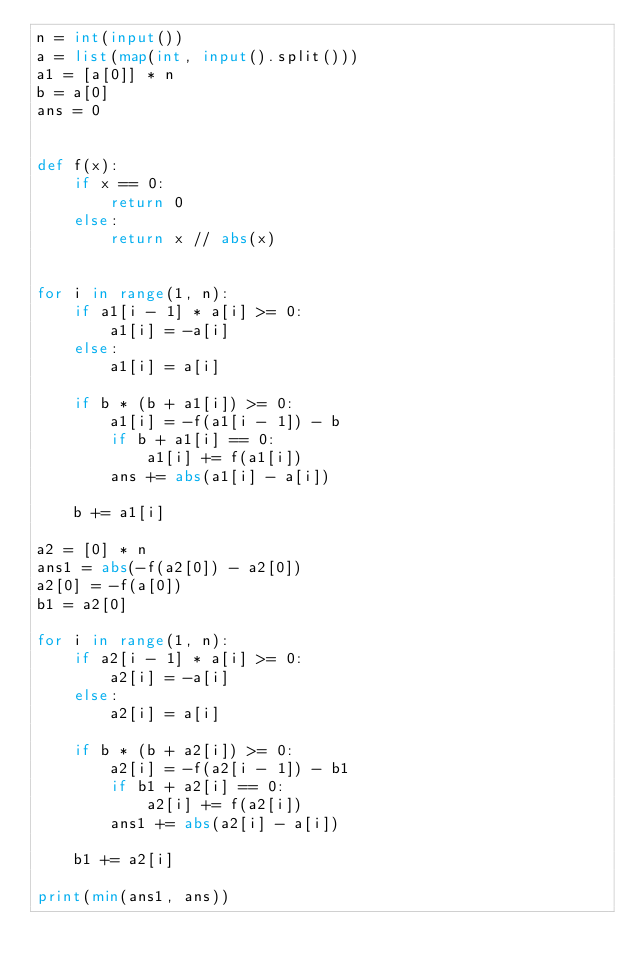Convert code to text. <code><loc_0><loc_0><loc_500><loc_500><_Python_>n = int(input())
a = list(map(int, input().split()))
a1 = [a[0]] * n
b = a[0]
ans = 0


def f(x):
    if x == 0:
        return 0
    else:
        return x // abs(x)


for i in range(1, n):
    if a1[i - 1] * a[i] >= 0:
        a1[i] = -a[i]
    else:
        a1[i] = a[i]

    if b * (b + a1[i]) >= 0:
        a1[i] = -f(a1[i - 1]) - b
        if b + a1[i] == 0:
            a1[i] += f(a1[i])
        ans += abs(a1[i] - a[i])

    b += a1[i]

a2 = [0] * n
ans1 = abs(-f(a2[0]) - a2[0])
a2[0] = -f(a[0])
b1 = a2[0]

for i in range(1, n):
    if a2[i - 1] * a[i] >= 0:
        a2[i] = -a[i]
    else:
        a2[i] = a[i]

    if b * (b + a2[i]) >= 0:
        a2[i] = -f(a2[i - 1]) - b1
        if b1 + a2[i] == 0:
            a2[i] += f(a2[i])
        ans1 += abs(a2[i] - a[i])

    b1 += a2[i]

print(min(ans1, ans))</code> 